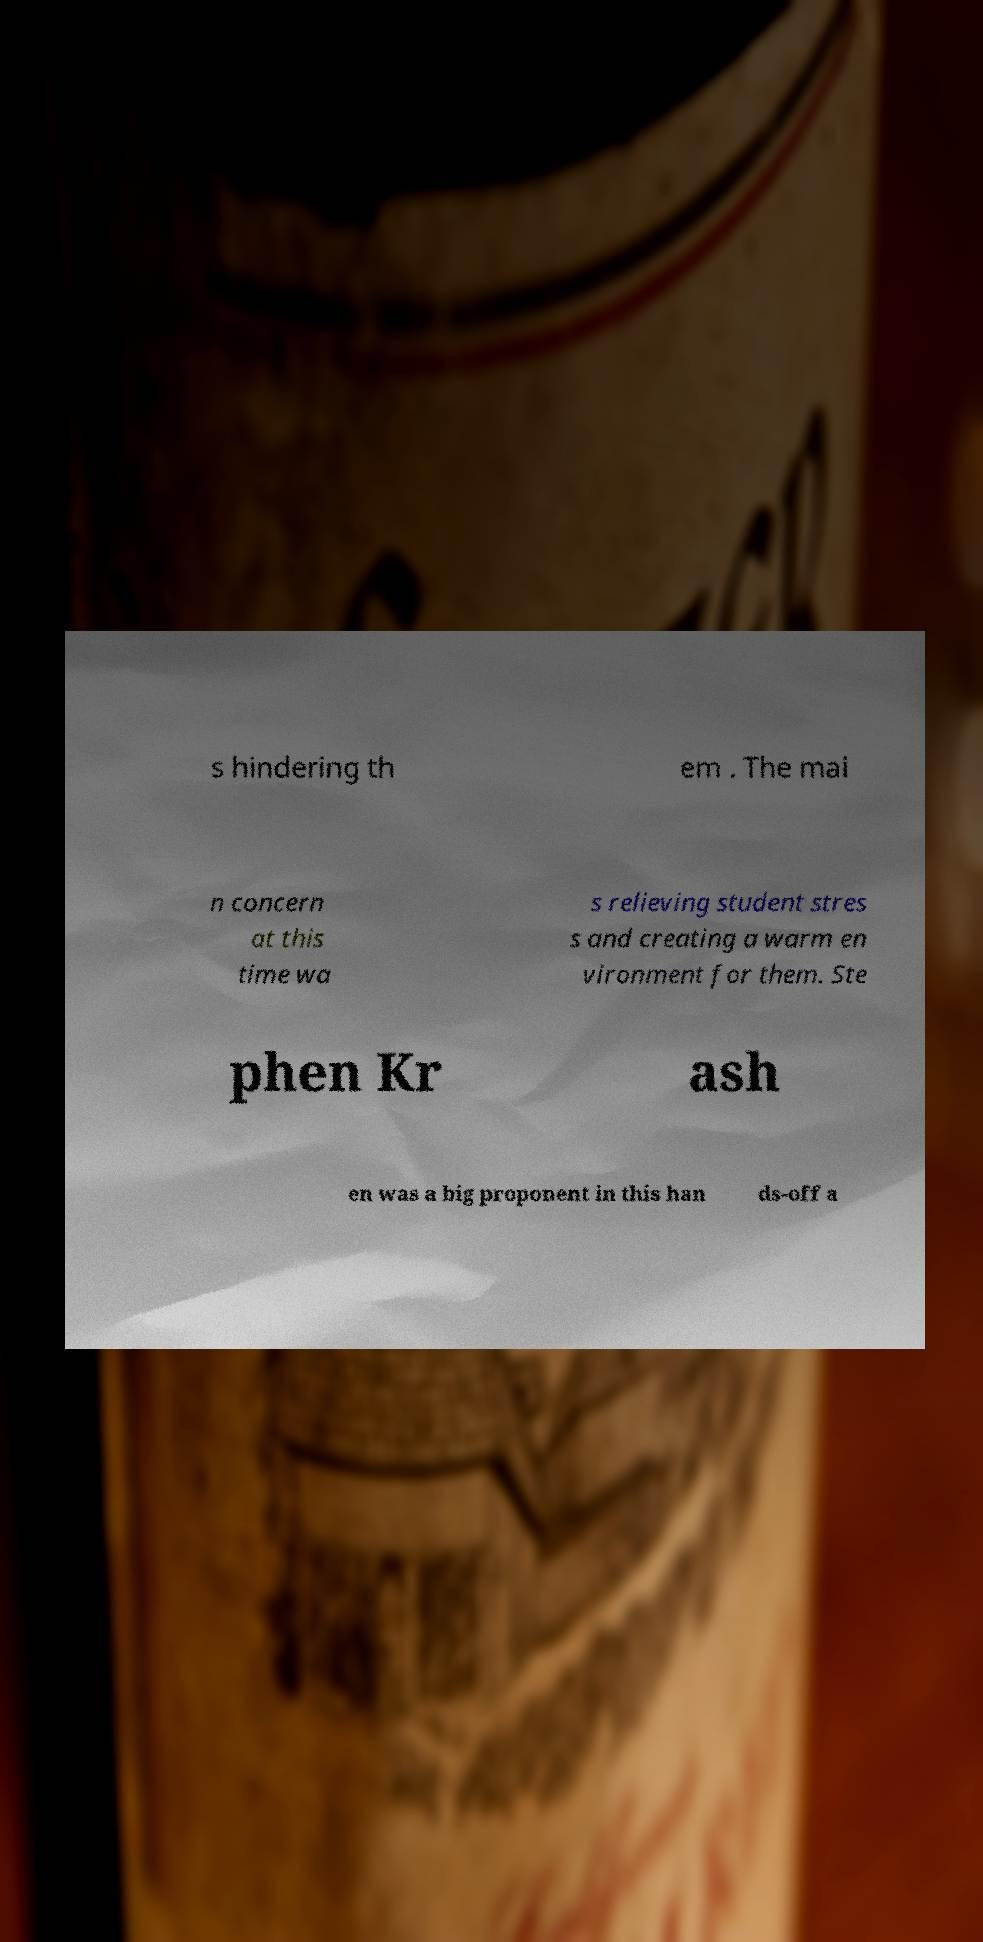There's text embedded in this image that I need extracted. Can you transcribe it verbatim? s hindering th em . The mai n concern at this time wa s relieving student stres s and creating a warm en vironment for them. Ste phen Kr ash en was a big proponent in this han ds-off a 